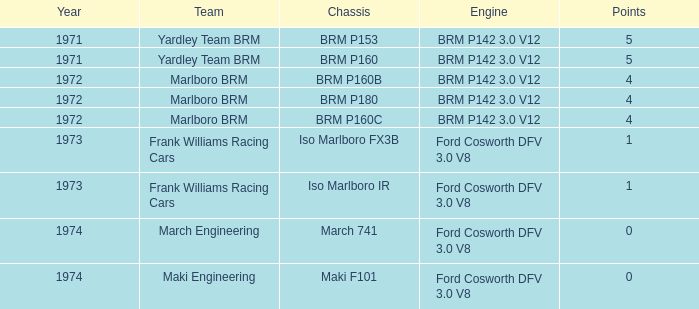What are the greatest achievements for the team of marlboro brm with brm p180 as their chassis? 4.0. 